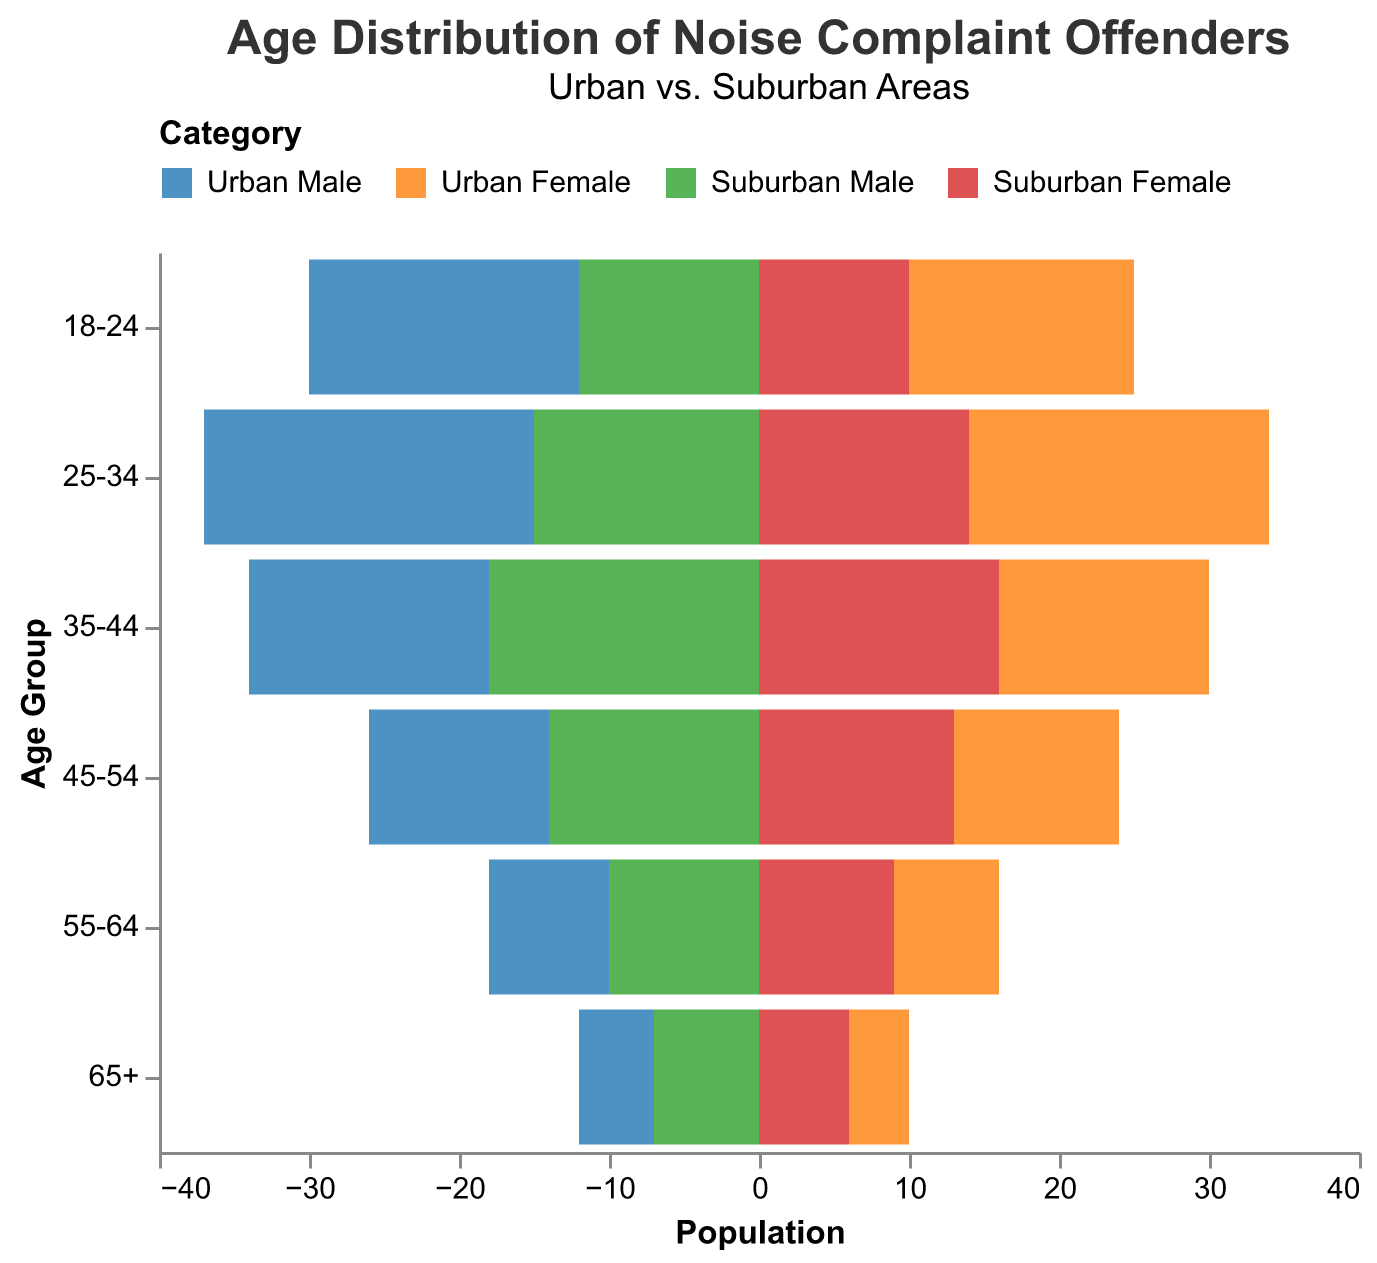What's the title of the figure? The title of the figure is displayed at the top and typically describes the main theme or content of the chart. Here, it states: "Age Distribution of Noise Complaint Offenders", with a subtitle "Urban vs. Suburban Areas".
Answer: Age Distribution of Noise Complaint Offenders What age group has the highest number of offenders in urban areas? To determine the highest number of offenders in urban areas, check the bar length for all urban categories. The age group 25-34 has the longest bars, representing the highest numbers (22 Urban Male and 20 Urban Female).
Answer: 25-34 How many total offenders are in the 35-44 age group in suburban areas? Add the values for Suburban Male and Suburban Female in the 35-44 age group. Suburban Male has 18, and Suburban Female has 16. So, 18 + 16 = 34.
Answer: 34 Which gender has more offenders in the 55-64 age group in urban areas? Compare the lengths of bars for Urban Male and Urban Female in the 55-64 age group. Urban Male has 8, and Urban Female has 7.
Answer: Male Are there more offenders aged 18-24 in urban or suburban areas? Sum the offenders in Urban and Suburban areas for the 18-24 age group. Urban: 18 (Male) + 15 (Female) = 33; Suburban: 12 (Male) + 10 (Female) = 22. Urban has more offenders.
Answer: Urban What is the difference in the number of suburban male offenders between the 25-34 and 45-54 age groups? Suburban Male offenders for 25-34 are 15, and for 45-54 they are 14. The difference is 15 - 14 = 1.
Answer: 1 How does the number of urban male offenders change from the 18-24 age group to the 65+ age group? Compare the Urban Male numbers for 18-24 and 65+ age groups. For 18-24, it is 18, and for 65+ it is 5. The change is 18 - 5 = 13.
Answer: Decreases by 13 Which age group in suburban areas has the most even distribution between male and female offenders? Evaluate the male and female offender numbers for each age group in suburban areas to see which are closest in value. The 55-64 age group has Suburban Male (10) and Suburban Female (9), which is the most even distribution.
Answer: 55-64 In the 25-34 age group, which area has more offenders, urban or suburban? Sum the offenders in Urban and Suburban areas for the 25-34 age group. Urban: 22 (Male) + 20 (Female) = 42; Suburban: 15 (Male) + 14 (Female) = 29. Urban has more offenders.
Answer: Urban What is the smallest group of offenders in the 65+ age group? Compare the numbers in the 65+ age group: Urban Male (5), Urban Female (4), Suburban Male (7), and Suburban Female (6). The smallest group is Urban Female with 4 offenders.
Answer: Urban Female 